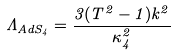Convert formula to latex. <formula><loc_0><loc_0><loc_500><loc_500>\Lambda _ { A d S _ { 4 } } = \frac { 3 ( T ^ { 2 } - 1 ) k ^ { 2 } } { \kappa _ { 4 } ^ { 2 } }</formula> 